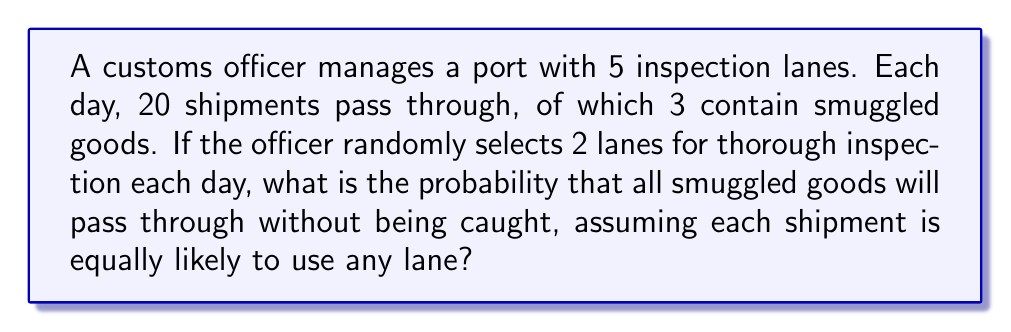Provide a solution to this math problem. Let's approach this step-by-step:

1) First, we need to calculate the probability that all 3 smuggled shipments will be in the 3 lanes that are not thoroughly inspected.

2) This is equivalent to choosing 3 lanes out of the 3 non-inspected lanes for the smuggled goods to pass through.

3) We can use the combination formula to calculate this:

   $$P(\text{all smuggled goods in non-inspected lanes}) = \frac{\binom{3}{3}}{\binom{5}{3}}$$

4) Here's how we calculate these combinations:

   $$\binom{3}{3} = 1$$
   $$\binom{5}{3} = \frac{5!}{3!(5-3)!} = \frac{5 \cdot 4 \cdot 3}{3 \cdot 2 \cdot 1} = 10$$

5) Therefore, the probability is:

   $$P(\text{all smuggled goods in non-inspected lanes}) = \frac{1}{10} = 0.1$$

6) This means there's a 10% chance that all smuggled goods will pass through without being caught.
Answer: The probability that all smuggled goods will pass through without being caught is $\frac{1}{10}$ or 0.1 or 10%. 